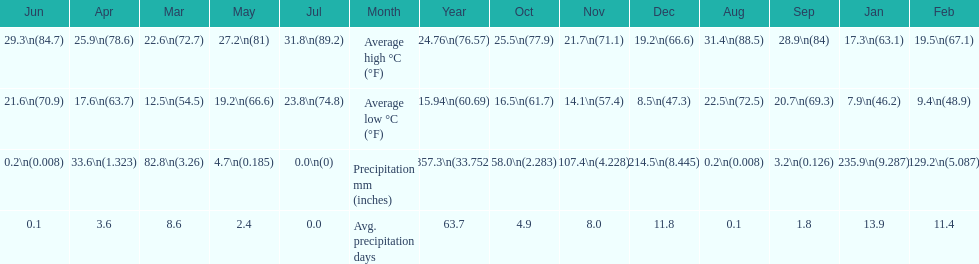Which month held the most precipitation? January. 